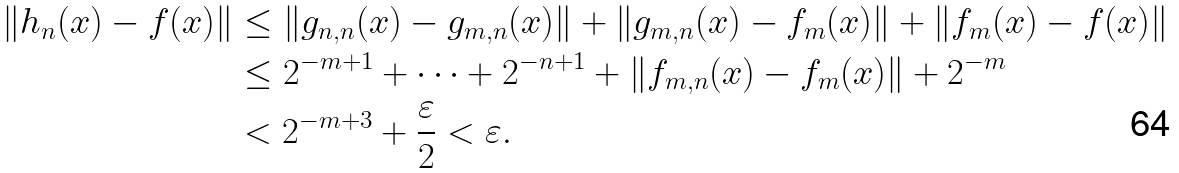Convert formula to latex. <formula><loc_0><loc_0><loc_500><loc_500>\| h _ { n } ( x ) - f ( x ) \| & \leq \| g _ { n , n } ( x ) - g _ { m , n } ( x ) \| + \| g _ { m , n } ( x ) - f _ { m } ( x ) \| + \| f _ { m } ( x ) - f ( x ) \| \\ & \leq 2 ^ { - m + 1 } + \dots + 2 ^ { - n + 1 } + \| f _ { m , n } ( x ) - f _ { m } ( x ) \| + 2 ^ { - m } \\ & < 2 ^ { - m + 3 } + \frac { \varepsilon } { 2 } < \varepsilon .</formula> 